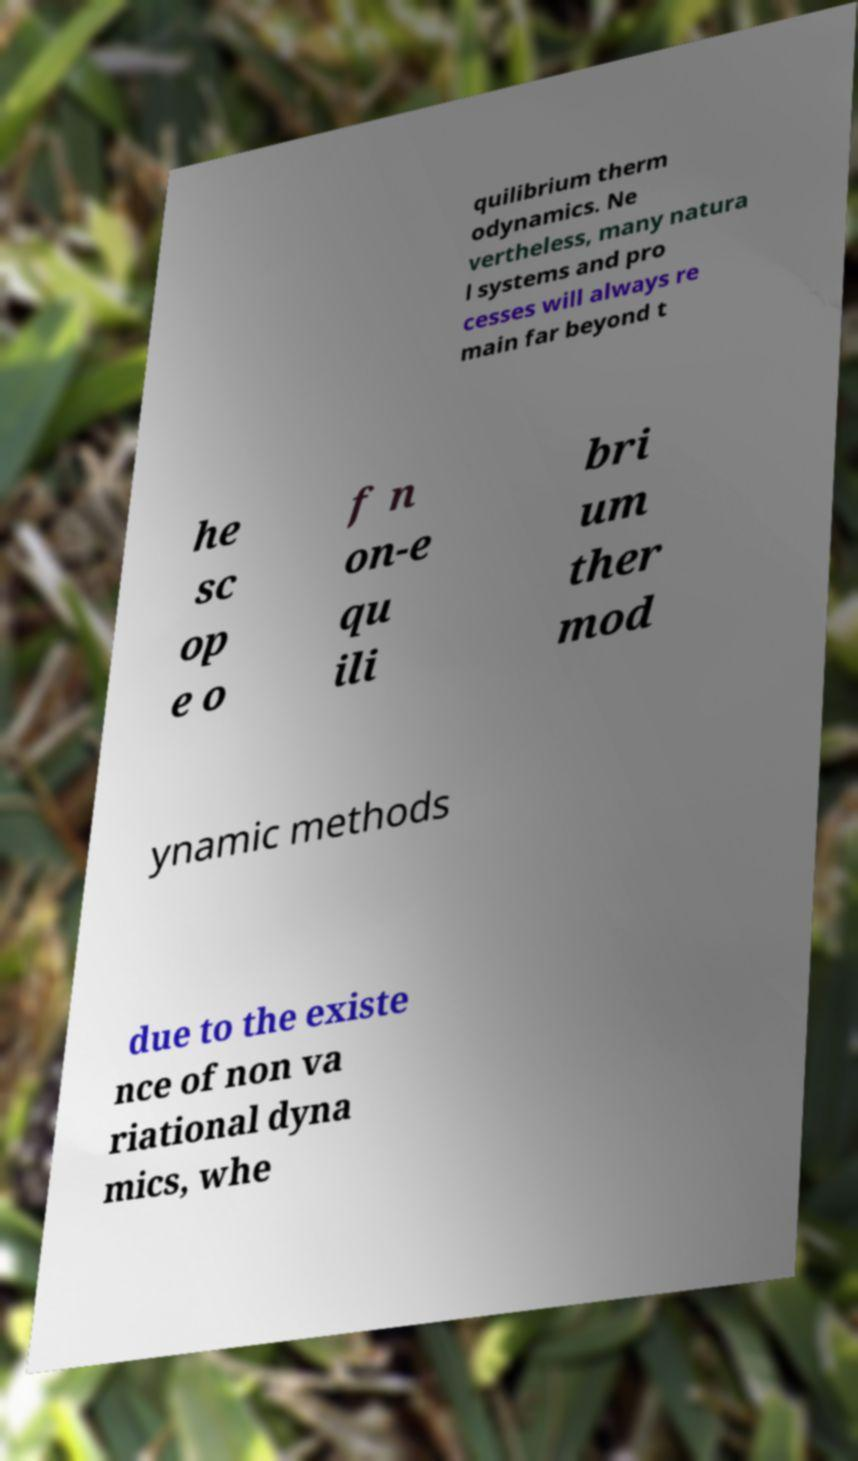Could you extract and type out the text from this image? quilibrium therm odynamics. Ne vertheless, many natura l systems and pro cesses will always re main far beyond t he sc op e o f n on-e qu ili bri um ther mod ynamic methods due to the existe nce of non va riational dyna mics, whe 